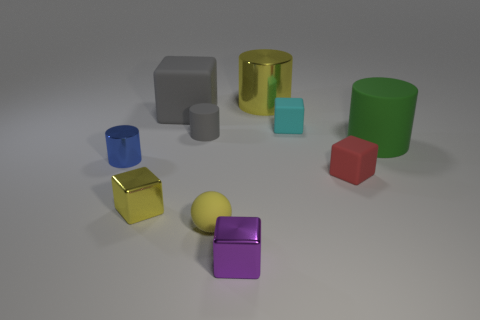Subtract all tiny rubber cylinders. How many cylinders are left? 3 Subtract all cyan cubes. How many cubes are left? 4 Subtract all balls. How many objects are left? 9 Subtract 4 blocks. How many blocks are left? 1 Subtract all brown spheres. Subtract all red cylinders. How many spheres are left? 1 Subtract all large green rubber things. Subtract all big cubes. How many objects are left? 8 Add 1 metal cylinders. How many metal cylinders are left? 3 Add 4 gray cylinders. How many gray cylinders exist? 5 Subtract 0 red spheres. How many objects are left? 10 Subtract all purple blocks. How many green cylinders are left? 1 